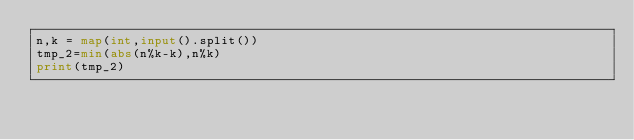<code> <loc_0><loc_0><loc_500><loc_500><_Python_>n,k = map(int,input().split())
tmp_2=min(abs(n%k-k),n%k)
print(tmp_2)
</code> 